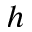Convert formula to latex. <formula><loc_0><loc_0><loc_500><loc_500>h</formula> 